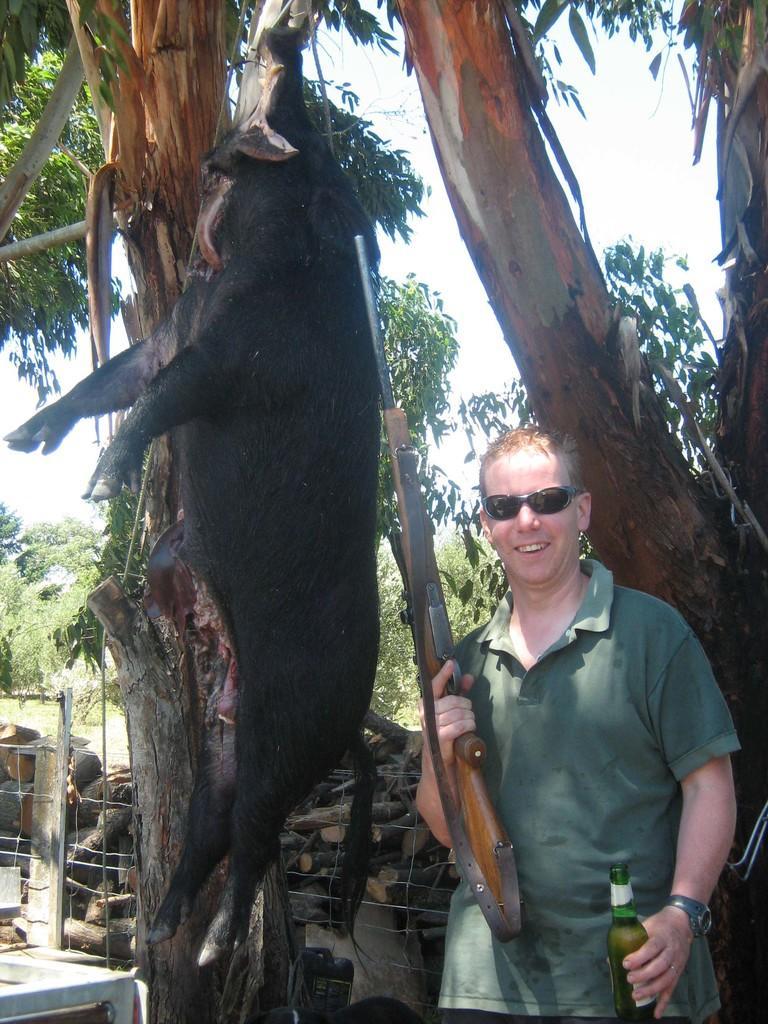How would you summarize this image in a sentence or two? In this image there is a person holding a gun and a bottle of beer in his hand is having a smile on his face is posing for the camera, beside the person there is a pig hanging on to a tree, behind the pig on the other side of the metal fence there are logs of wood and there are trees. 